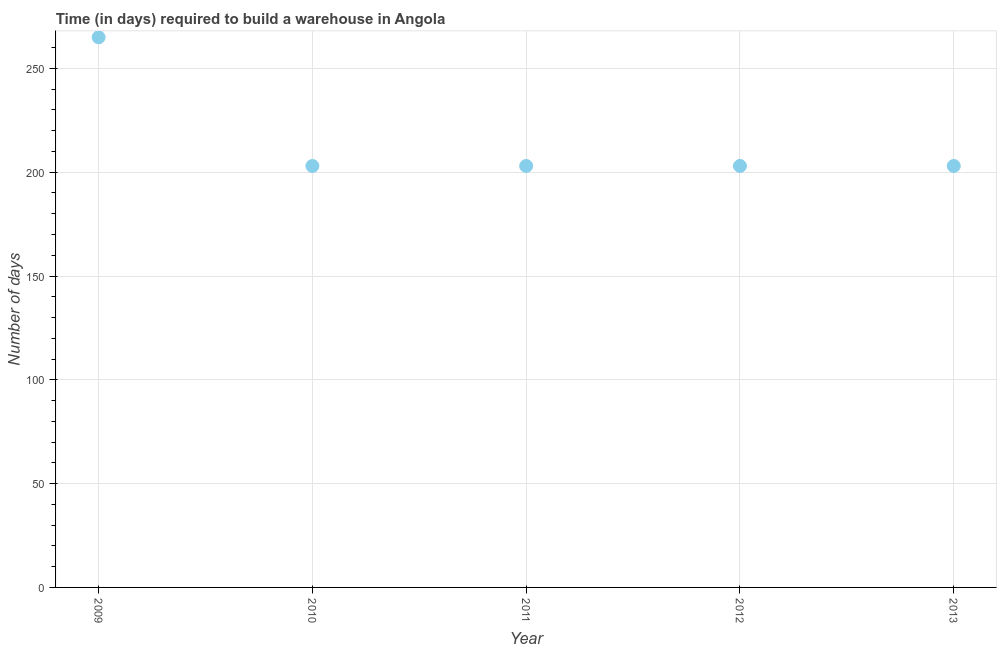What is the time required to build a warehouse in 2011?
Make the answer very short. 203. Across all years, what is the maximum time required to build a warehouse?
Your answer should be very brief. 265. Across all years, what is the minimum time required to build a warehouse?
Your answer should be compact. 203. What is the sum of the time required to build a warehouse?
Your response must be concise. 1077. What is the difference between the time required to build a warehouse in 2009 and 2011?
Make the answer very short. 62. What is the average time required to build a warehouse per year?
Your response must be concise. 215.4. What is the median time required to build a warehouse?
Your answer should be compact. 203. In how many years, is the time required to build a warehouse greater than 130 days?
Keep it short and to the point. 5. Do a majority of the years between 2012 and 2011 (inclusive) have time required to build a warehouse greater than 50 days?
Your answer should be very brief. No. What is the ratio of the time required to build a warehouse in 2009 to that in 2011?
Give a very brief answer. 1.31. Is the time required to build a warehouse in 2009 less than that in 2013?
Offer a terse response. No. Is the difference between the time required to build a warehouse in 2010 and 2013 greater than the difference between any two years?
Ensure brevity in your answer.  No. Is the sum of the time required to build a warehouse in 2010 and 2012 greater than the maximum time required to build a warehouse across all years?
Your answer should be very brief. Yes. What is the difference between the highest and the lowest time required to build a warehouse?
Provide a short and direct response. 62. In how many years, is the time required to build a warehouse greater than the average time required to build a warehouse taken over all years?
Your response must be concise. 1. Does the graph contain any zero values?
Offer a very short reply. No. What is the title of the graph?
Offer a terse response. Time (in days) required to build a warehouse in Angola. What is the label or title of the X-axis?
Your answer should be compact. Year. What is the label or title of the Y-axis?
Offer a terse response. Number of days. What is the Number of days in 2009?
Your response must be concise. 265. What is the Number of days in 2010?
Keep it short and to the point. 203. What is the Number of days in 2011?
Give a very brief answer. 203. What is the Number of days in 2012?
Offer a terse response. 203. What is the Number of days in 2013?
Offer a very short reply. 203. What is the difference between the Number of days in 2009 and 2010?
Provide a short and direct response. 62. What is the difference between the Number of days in 2009 and 2011?
Your answer should be compact. 62. What is the difference between the Number of days in 2009 and 2013?
Your answer should be very brief. 62. What is the difference between the Number of days in 2011 and 2012?
Give a very brief answer. 0. What is the difference between the Number of days in 2011 and 2013?
Keep it short and to the point. 0. What is the ratio of the Number of days in 2009 to that in 2010?
Your response must be concise. 1.3. What is the ratio of the Number of days in 2009 to that in 2011?
Your response must be concise. 1.3. What is the ratio of the Number of days in 2009 to that in 2012?
Keep it short and to the point. 1.3. What is the ratio of the Number of days in 2009 to that in 2013?
Your answer should be compact. 1.3. What is the ratio of the Number of days in 2010 to that in 2011?
Your response must be concise. 1. What is the ratio of the Number of days in 2010 to that in 2013?
Offer a very short reply. 1. What is the ratio of the Number of days in 2011 to that in 2012?
Ensure brevity in your answer.  1. What is the ratio of the Number of days in 2011 to that in 2013?
Your answer should be compact. 1. What is the ratio of the Number of days in 2012 to that in 2013?
Make the answer very short. 1. 